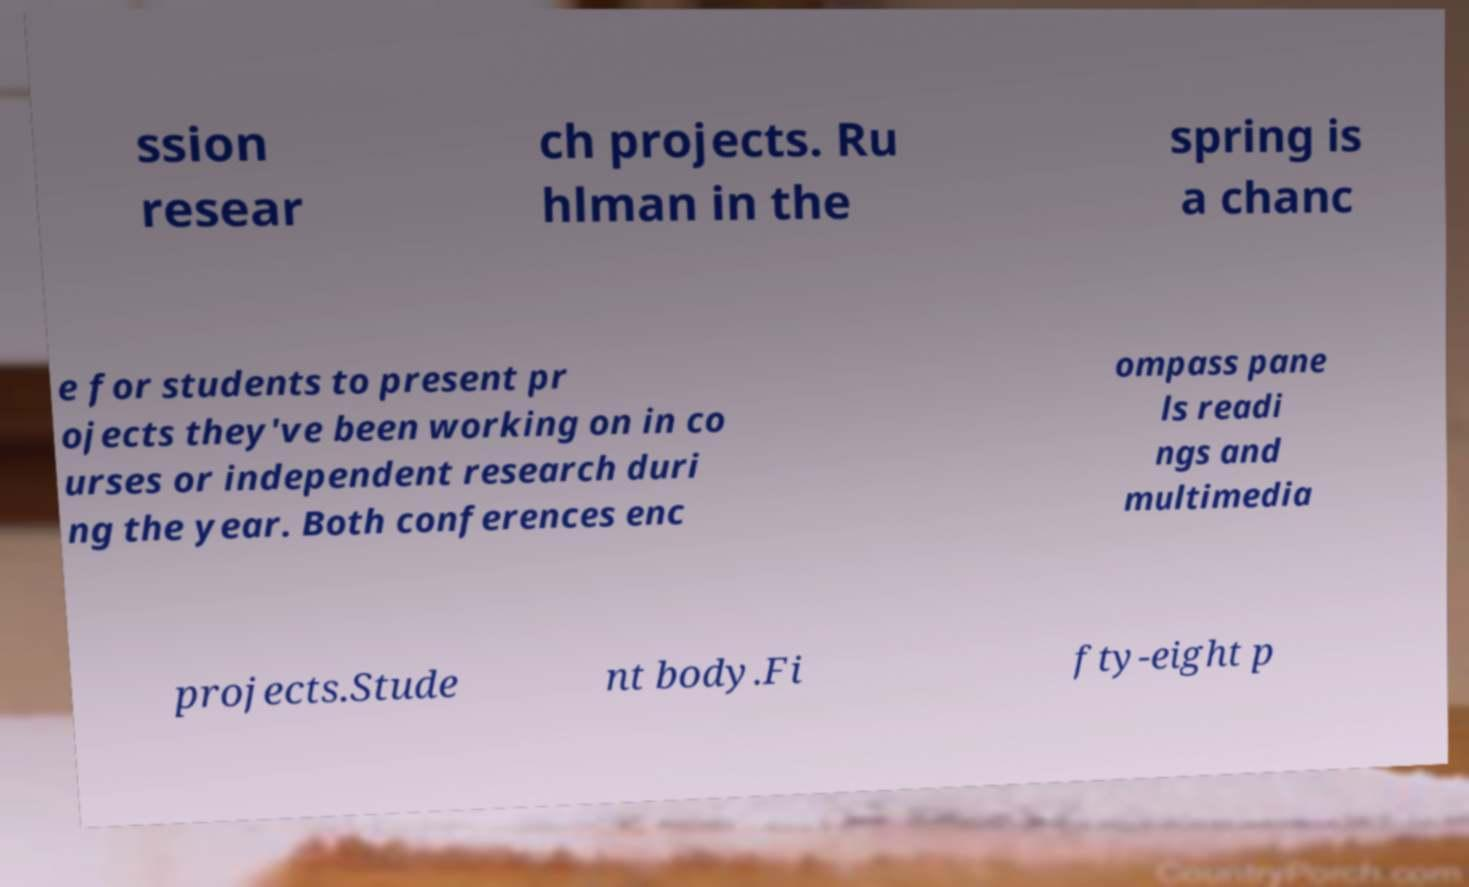For documentation purposes, I need the text within this image transcribed. Could you provide that? ssion resear ch projects. Ru hlman in the spring is a chanc e for students to present pr ojects they've been working on in co urses or independent research duri ng the year. Both conferences enc ompass pane ls readi ngs and multimedia projects.Stude nt body.Fi fty-eight p 